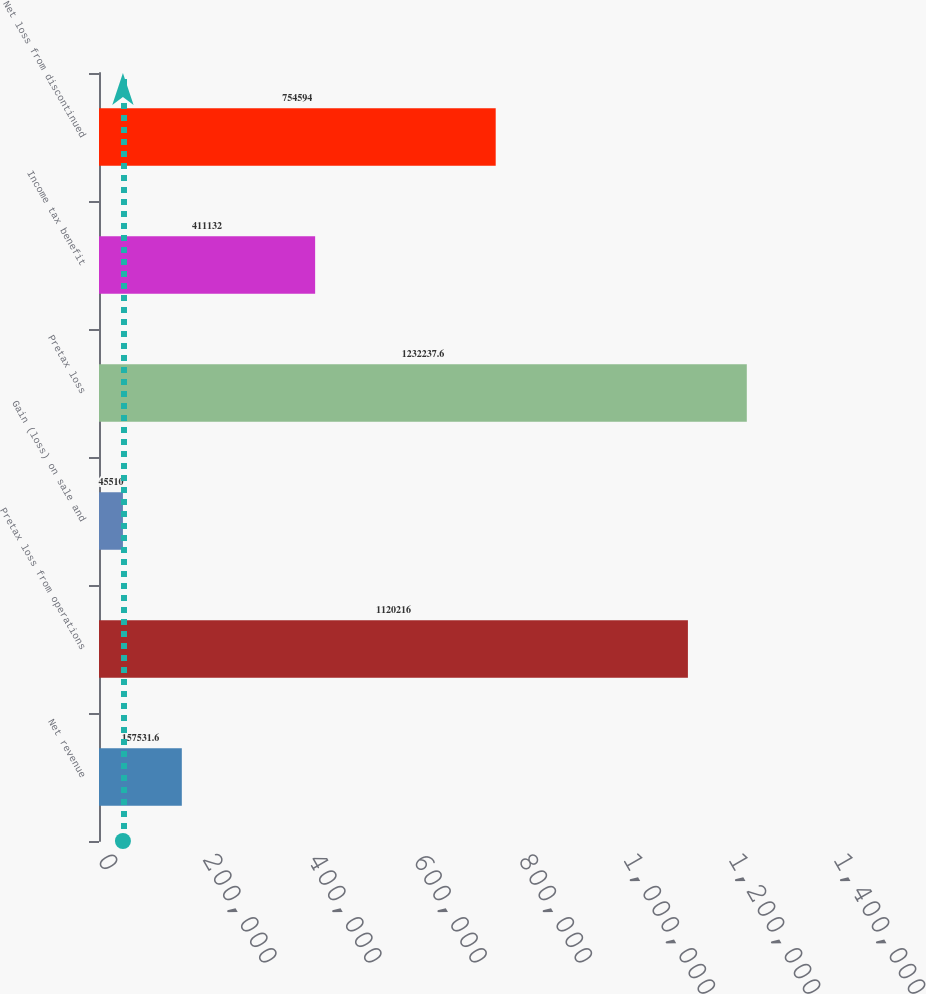<chart> <loc_0><loc_0><loc_500><loc_500><bar_chart><fcel>Net revenue<fcel>Pretax loss from operations<fcel>Gain (loss) on sale and<fcel>Pretax loss<fcel>Income tax benefit<fcel>Net loss from discontinued<nl><fcel>157532<fcel>1.12022e+06<fcel>45510<fcel>1.23224e+06<fcel>411132<fcel>754594<nl></chart> 